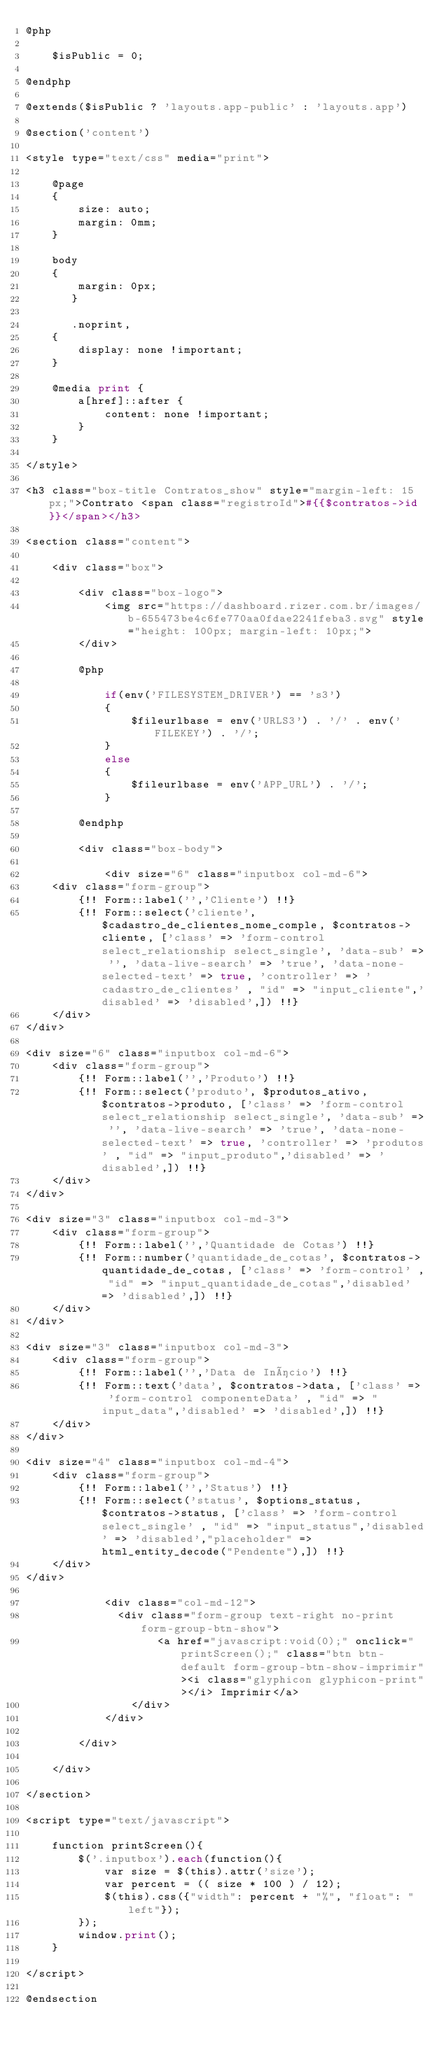<code> <loc_0><loc_0><loc_500><loc_500><_PHP_>@php

    $isPublic = 0;

@endphp

@extends($isPublic ? 'layouts.app-public' : 'layouts.app')

@section('content')

<style type="text/css" media="print">

    @page 
    {
        size: auto;
        margin: 0mm;
    }

    body 
    {
        margin: 0px;
       }

       .noprint,
    {  
        display: none !important;
    }

    @media print {
        a[href]::after {
            content: none !important;
        }
    }

</style>

<h3 class="box-title Contratos_show" style="margin-left: 15px;">Contrato <span class="registroId">#{{$contratos->id}}</span></h3>

<section class="content">

    <div class="box">

        <div class="box-logo">
            <img src="https://dashboard.rizer.com.br/images/b-655473be4c6fe770aa0fdae2241feba3.svg" style="height: 100px; margin-left: 10px;">
        </div>

        @php

            if(env('FILESYSTEM_DRIVER') == 's3')
            {
                $fileurlbase = env('URLS3') . '/' . env('FILEKEY') . '/';
            }
            else
            {
                $fileurlbase = env('APP_URL') . '/';
            }

        @endphp

        <div class="box-body">

            <div size="6" class="inputbox col-md-6">
    <div class="form-group">
        {!! Form::label('','Cliente') !!}
        {!! Form::select('cliente', $cadastro_de_clientes_nome_comple, $contratos->cliente, ['class' => 'form-control select_relationship select_single', 'data-sub' => '', 'data-live-search' => 'true', 'data-none-selected-text' => true, 'controller' => 'cadastro_de_clientes' , "id" => "input_cliente",'disabled' => 'disabled',]) !!}
    </div>
</div>

<div size="6" class="inputbox col-md-6">
    <div class="form-group">
        {!! Form::label('','Produto') !!}
        {!! Form::select('produto', $produtos_ativo, $contratos->produto, ['class' => 'form-control select_relationship select_single', 'data-sub' => '', 'data-live-search' => 'true', 'data-none-selected-text' => true, 'controller' => 'produtos' , "id" => "input_produto",'disabled' => 'disabled',]) !!}
    </div>
</div>

<div size="3" class="inputbox col-md-3">
    <div class="form-group">
        {!! Form::label('','Quantidade de Cotas') !!}
        {!! Form::number('quantidade_de_cotas', $contratos->quantidade_de_cotas, ['class' => 'form-control' , "id" => "input_quantidade_de_cotas",'disabled' => 'disabled',]) !!}
    </div>
</div>

<div size="3" class="inputbox col-md-3">
    <div class="form-group">
        {!! Form::label('','Data de Início') !!}
        {!! Form::text('data', $contratos->data, ['class' => 'form-control componenteData' , "id" => "input_data",'disabled' => 'disabled',]) !!}
    </div>
</div>

<div size="4" class="inputbox col-md-4">
    <div class="form-group">
        {!! Form::label('','Status') !!}
        {!! Form::select('status', $options_status, $contratos->status, ['class' => 'form-control select_single' , "id" => "input_status",'disabled' => 'disabled',"placeholder" => html_entity_decode("Pendente"),]) !!}
    </div>
</div>

            <div class="col-md-12">
        	    <div class="form-group text-right no-print form-group-btn-show">
                    <a href="javascript:void(0);" onclick="printScreen();" class="btn btn-default form-group-btn-show-imprimir"><i class="glyphicon glyphicon-print"></i> Imprimir</a>
                </div>
            </div>

        </div>

    </div>

</section>

<script type="text/javascript">

    function printScreen(){
        $('.inputbox').each(function(){
            var size = $(this).attr('size');
            var percent = (( size * 100 ) / 12);
            $(this).css({"width": percent + "%", "float": "left"});
        });
        window.print();
    }

</script>

@endsection</code> 